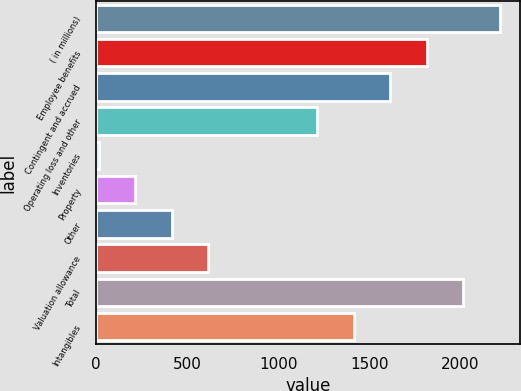Convert chart. <chart><loc_0><loc_0><loc_500><loc_500><bar_chart><fcel>( in millions)<fcel>Employee benefits<fcel>Contingent and accrued<fcel>Operating loss and other<fcel>Inventories<fcel>Property<fcel>Other<fcel>Valuation allowance<fcel>Total<fcel>Intangibles<nl><fcel>2215.1<fcel>1814.9<fcel>1614.8<fcel>1214.6<fcel>14<fcel>214.1<fcel>414.2<fcel>614.3<fcel>2015<fcel>1414.7<nl></chart> 